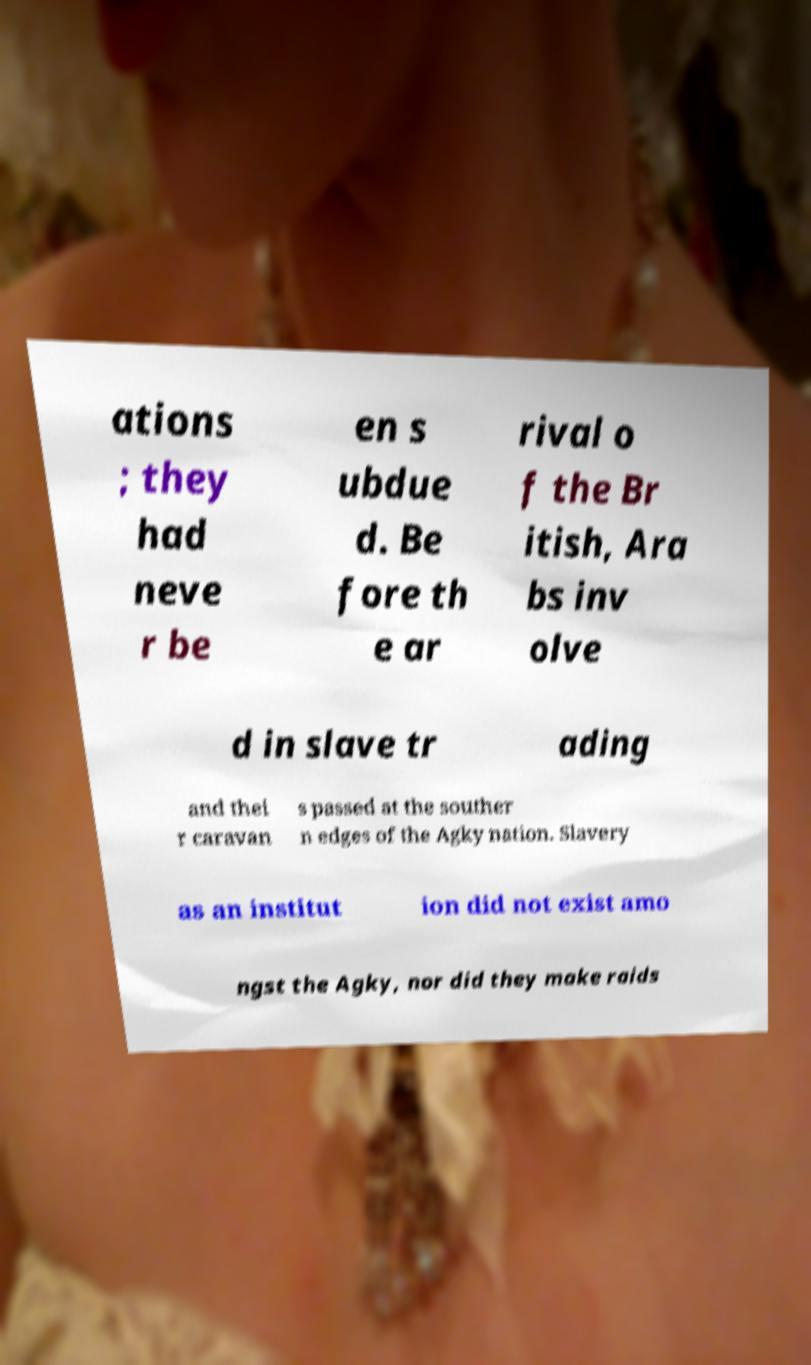Please read and relay the text visible in this image. What does it say? ations ; they had neve r be en s ubdue d. Be fore th e ar rival o f the Br itish, Ara bs inv olve d in slave tr ading and thei r caravan s passed at the souther n edges of the Agky nation. Slavery as an institut ion did not exist amo ngst the Agky, nor did they make raids 